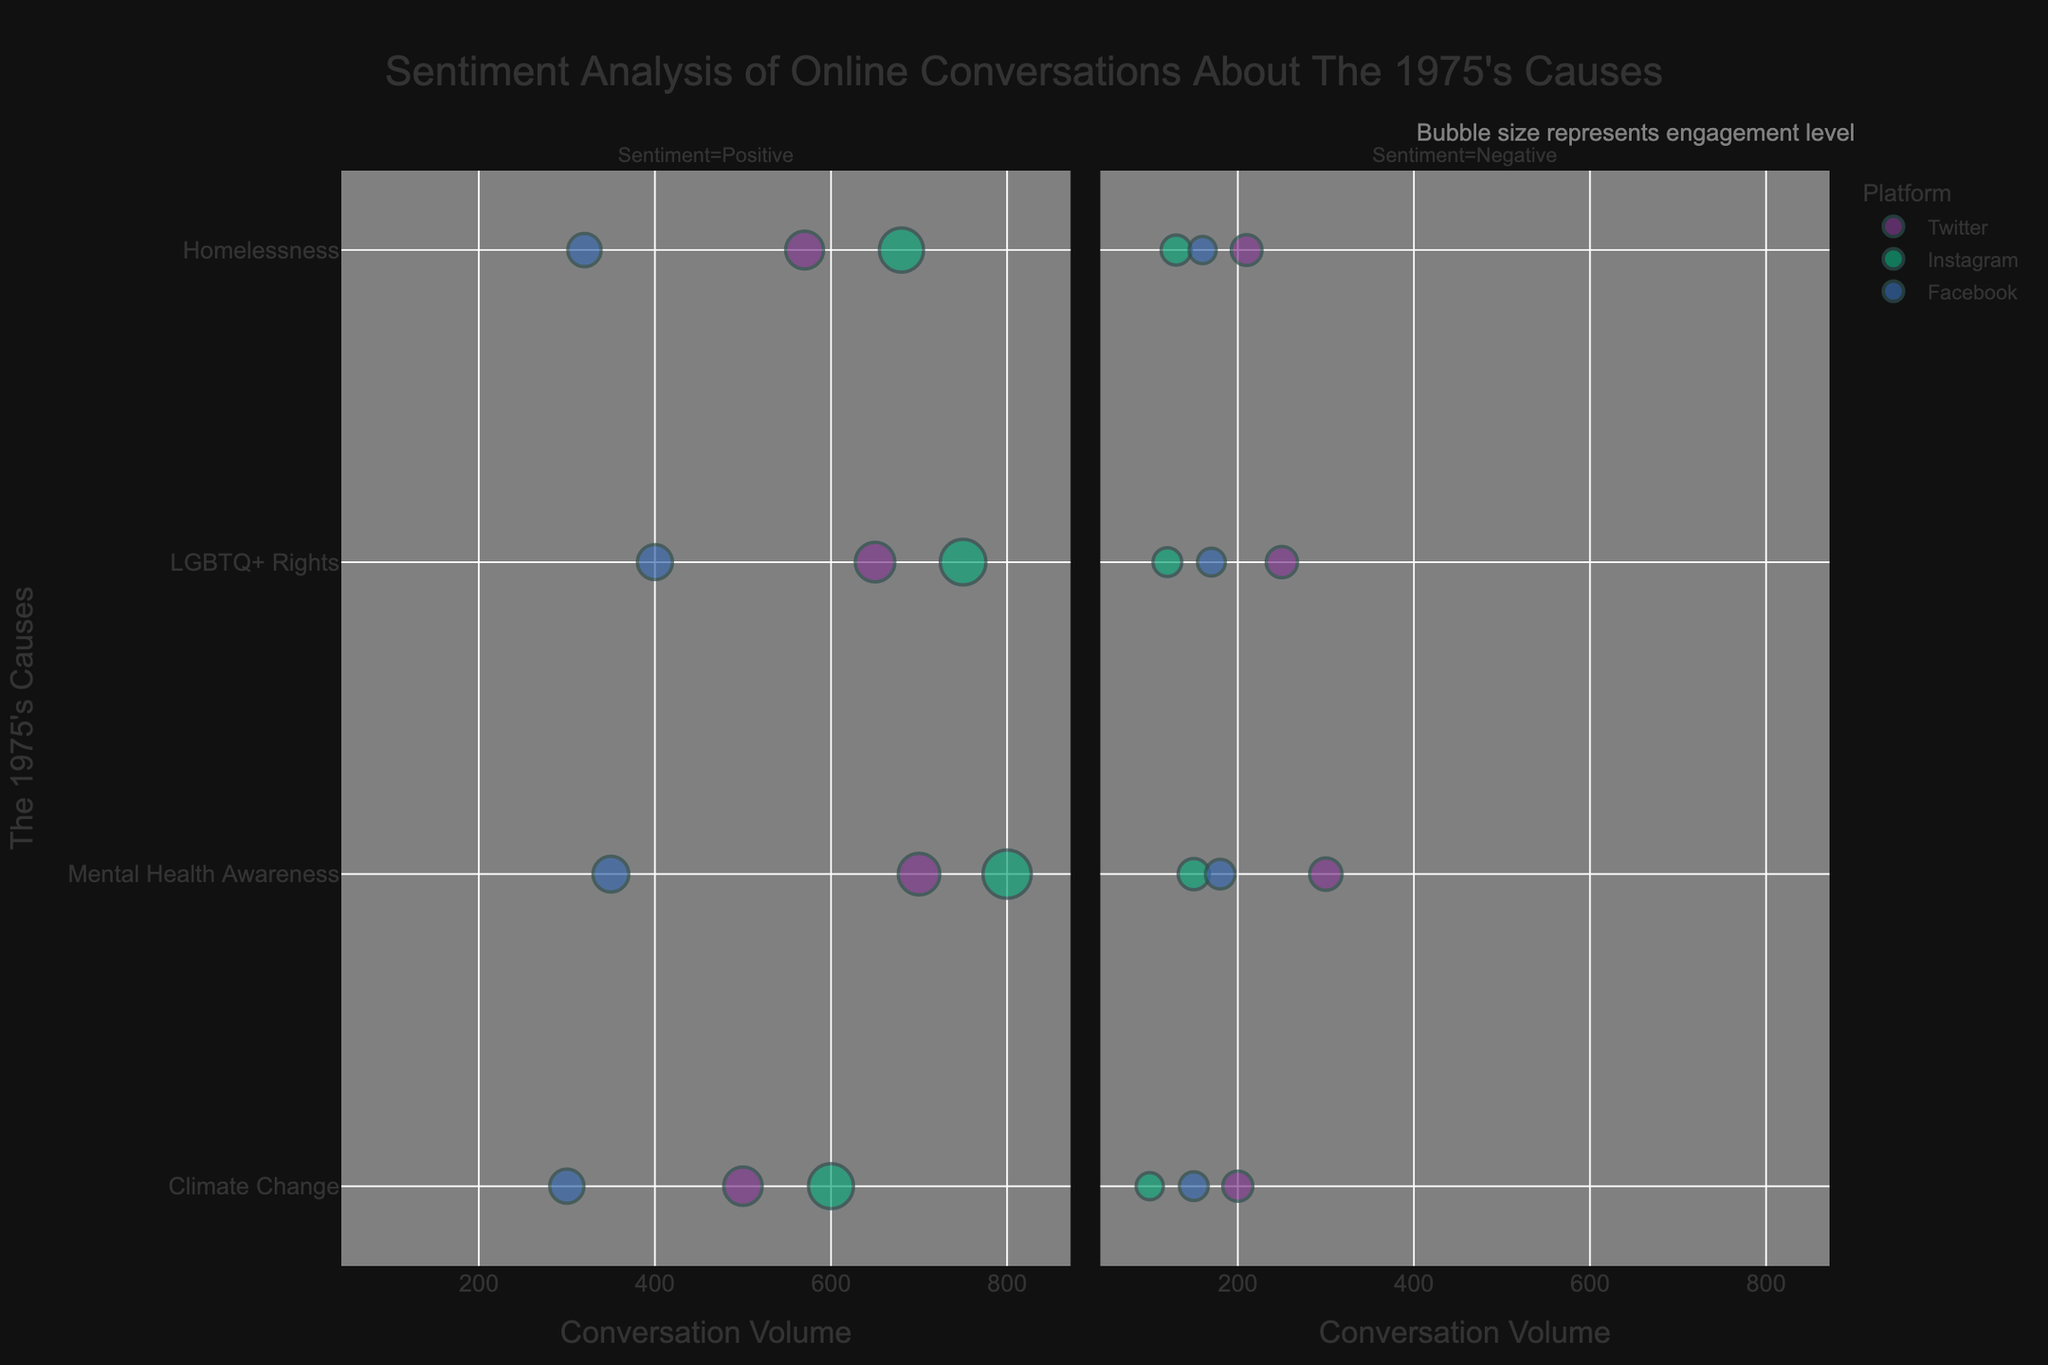What's the title of the chart? The title is typically displayed at the top of the chart. Here, it reads "Sentiment Analysis of Online Conversations About The 1975's Causes", which summarizes the figure's content.
Answer: Sentiment Analysis of Online Conversations About The 1975's Causes How is the bubble size determined in this chart? Bubble size is determined by the level of engagement. This is indicated by the annotation text: "Bubble size represents engagement level".
Answer: Level of engagement Which platform has the highest positive conversation volume about Climate Change? Look at the 'Positive' sentiment column for the 'Climate Change' topic and compare the 'Volume' values of different platforms. Instagram has the highest volume with 600 conversations.
Answer: Instagram Among the platforms, where does The 1975's Mental Health Awareness initiative have the most negative conversations? Check the 'Negative' sentiment column for the 'Mental Health Awareness' topic and compare 'Volume' values. Twitter shows the highest volume with 300 negative conversations.
Answer: Twitter Which cause has the highest engagement level on Instagram according to the positive sentiment column? Look at the bubbles representing the 'Positive' sentiment on Instagram and compare their sizes. Mental Health Awareness has the highest engagement with 200.
Answer: Mental Health Awareness Compare the total positive conversation volume for Homelessness between Twitter and Facebook. Which platform has more? Sum the 'Positive' conversation volumes for Homelessness on Twitter and Facebook. Twitter has 570, and Facebook has 320. Comparing these, Twitter has more positive conversations about Homelessness.
Answer: Twitter How does the volume of negative conversations about LGBTQ+ Rights on Instagram compare to Facebook? Check the 'Negative' sentiment volumes for 'LGBTQ+ Rights' on both Instagram and Facebook. Instagram has 120, and Facebook has 170. Facebook has a higher volume.
Answer: Facebook What can be inferred about the cause engagement on Instagram compared to Twitter? Compare the sizes of bubbles for both platforms across all causes. Instagram generally has larger bubbles, indicating higher engagement across various causes.
Answer: Instagram has higher engagement In terms of overall volume, which cause does Twitter show the most engagement in, considering both positive and negative sentiments? Add the positive and negative sentiment volumes for each cause on Twitter. Mental Health Awareness has 700 (positive) + 300 (negative) = 1000, which is the highest.
Answer: Mental Health Awareness Which platform exhibits the broadest distribution of topics in terms of engagement levels for each sentiment? Look at the distribution and sizes of bubbles across each sentiment column. Engagement levels vary widely across all topics on Instagram, indicating a broad distribution.
Answer: Instagram 